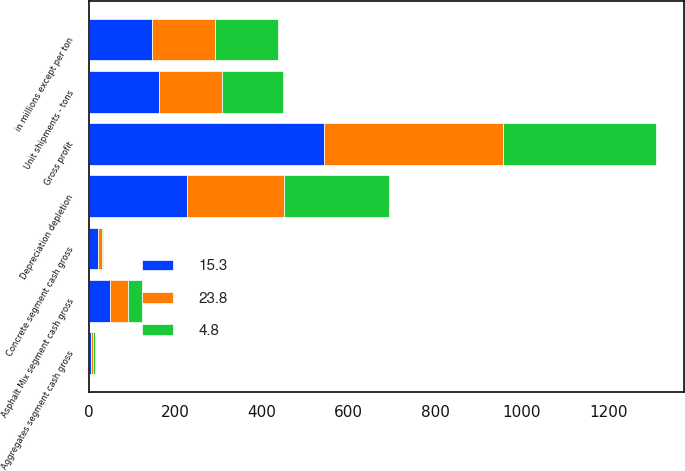<chart> <loc_0><loc_0><loc_500><loc_500><stacked_bar_chart><ecel><fcel>in millions except per ton<fcel>Gross profit<fcel>Depreciation depletion<fcel>Aggregates segment cash gross<fcel>Unit shipments - tons<fcel>Asphalt Mix segment cash gross<fcel>Concrete segment cash gross<nl><fcel>15.3<fcel>145.9<fcel>544.1<fcel>227<fcel>4.75<fcel>162.4<fcel>48.8<fcel>22.1<nl><fcel>23.8<fcel>145.9<fcel>413.3<fcel>224.8<fcel>4.37<fcel>145.9<fcel>41.4<fcel>8.2<nl><fcel>4.8<fcel>145.9<fcel>352.1<fcel>240.7<fcel>4.21<fcel>141<fcel>31.6<fcel>3.1<nl></chart> 